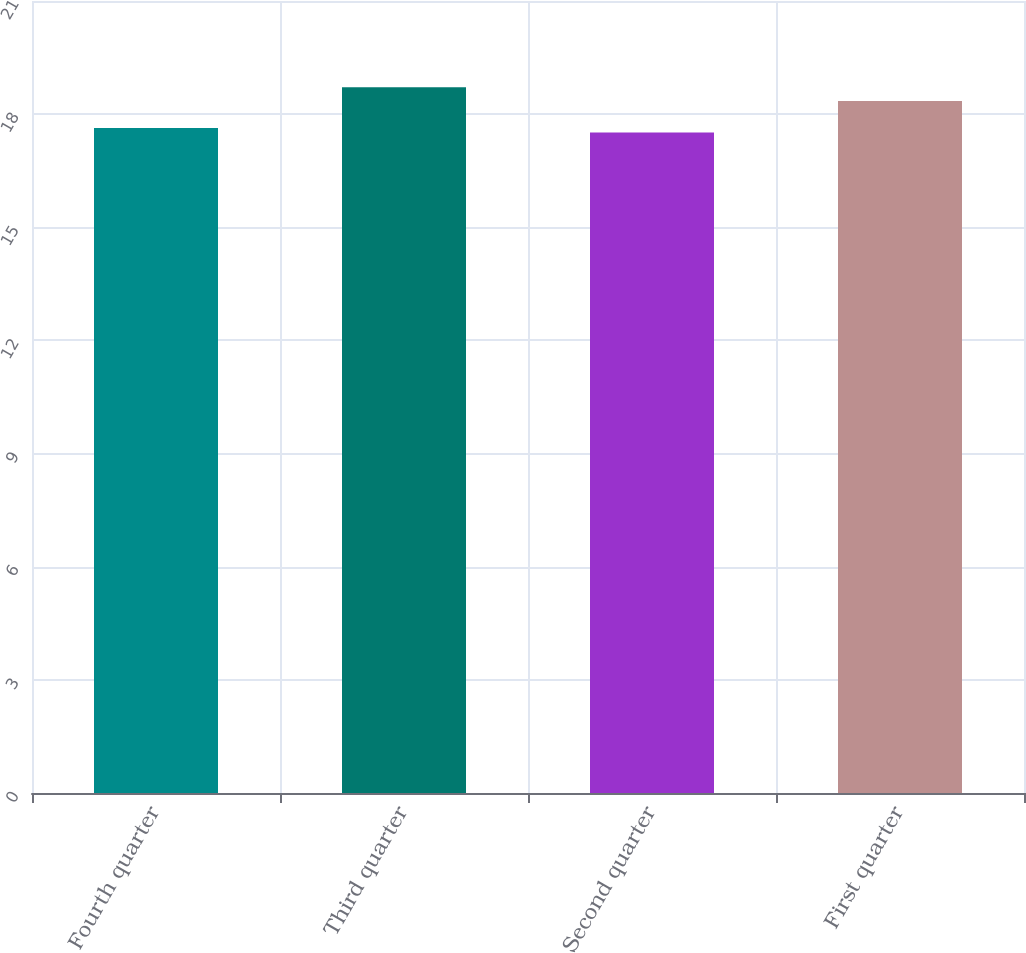Convert chart. <chart><loc_0><loc_0><loc_500><loc_500><bar_chart><fcel>Fourth quarter<fcel>Third quarter<fcel>Second quarter<fcel>First quarter<nl><fcel>17.63<fcel>18.71<fcel>17.51<fcel>18.35<nl></chart> 